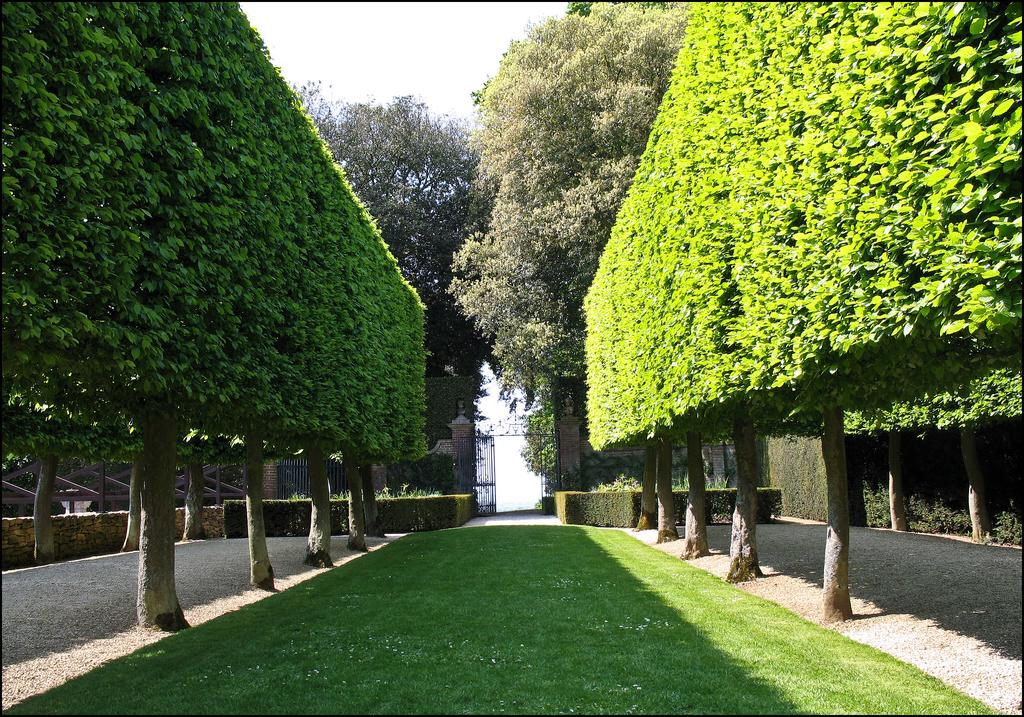What is the main feature in the middle of the image? There is a garden in the middle of the image. What can be seen on either side of the garden? Trees are present on either side of the garden. Where is the gate located in the image? There is a gate in the back of the image. What is on either side of the gate? Plants are on either side of the gate. What is visible above the gate? The sky is visible above the gate. Can you see a lift in the image? There is no lift present in the image. Is there a crack in the gate in the image? The image does not show any cracks in the gate. 